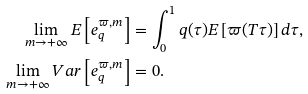Convert formula to latex. <formula><loc_0><loc_0><loc_500><loc_500>\lim _ { m \rightarrow + \infty } E \left [ e _ { q } ^ { \varpi , m } \right ] & = \int _ { 0 } ^ { 1 } q ( \tau ) E \left [ \varpi ( T \tau ) \right ] d \tau , \\ \lim _ { m \rightarrow + \infty } V a r \left [ e _ { q } ^ { \varpi , m } \right ] & = 0 .</formula> 